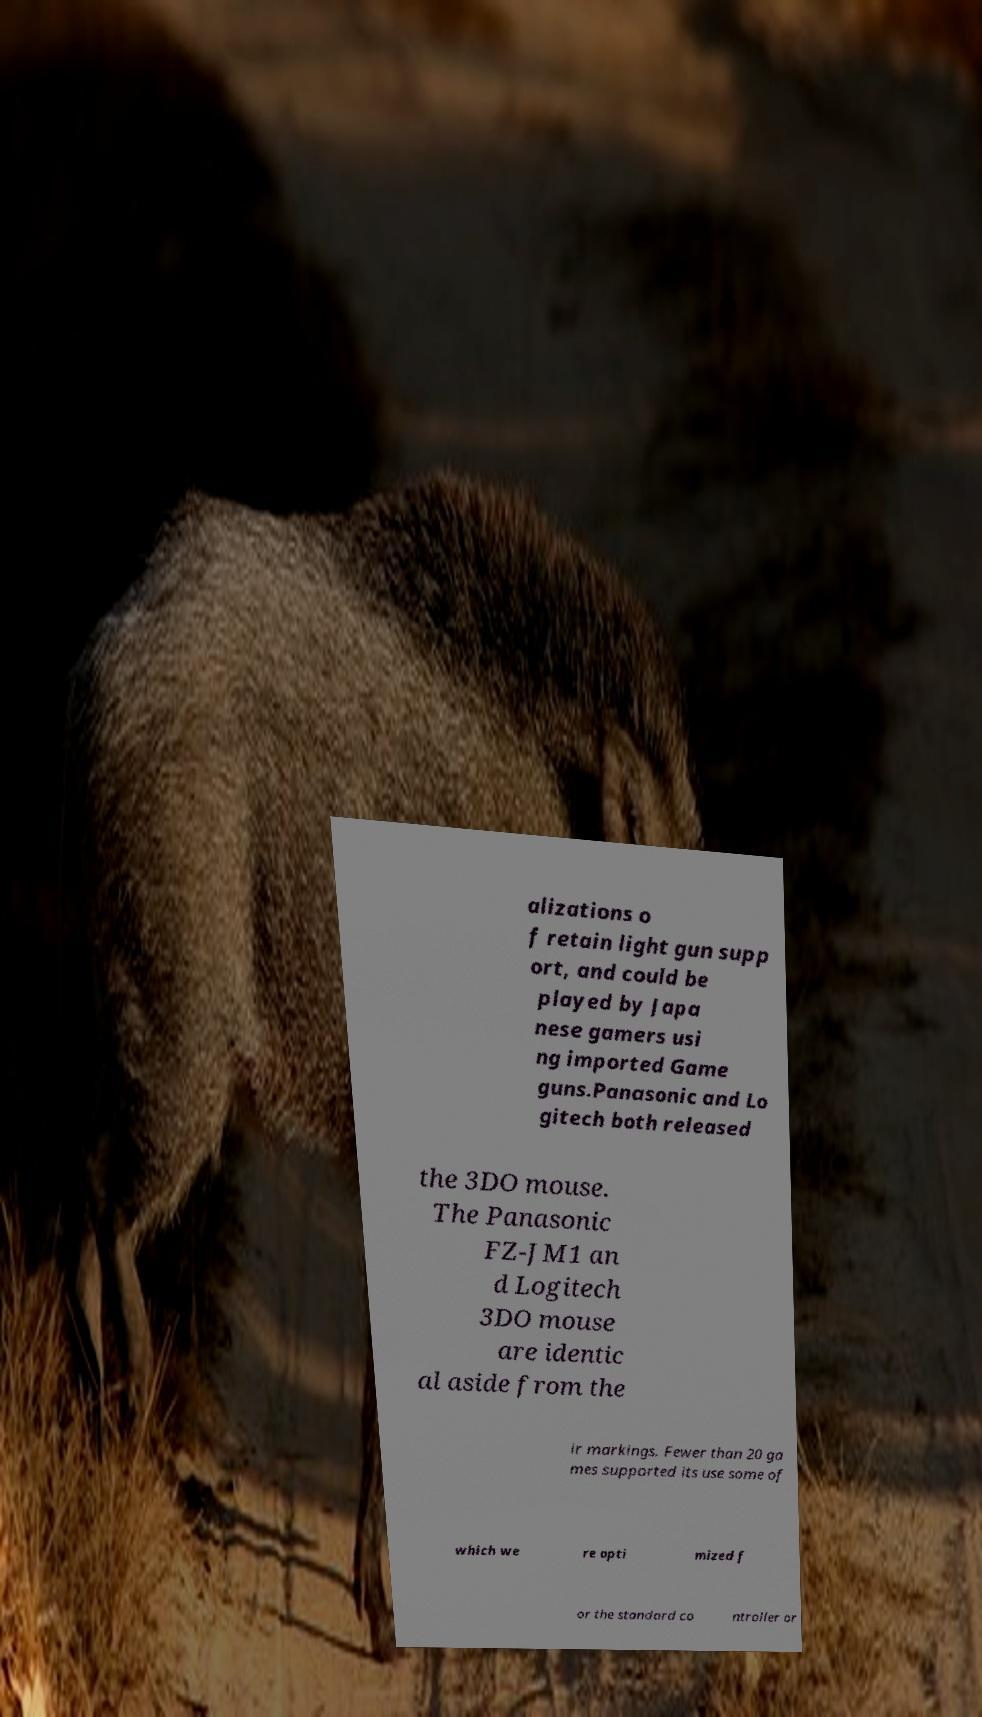Could you assist in decoding the text presented in this image and type it out clearly? alizations o f retain light gun supp ort, and could be played by Japa nese gamers usi ng imported Game guns.Panasonic and Lo gitech both released the 3DO mouse. The Panasonic FZ-JM1 an d Logitech 3DO mouse are identic al aside from the ir markings. Fewer than 20 ga mes supported its use some of which we re opti mized f or the standard co ntroller or 